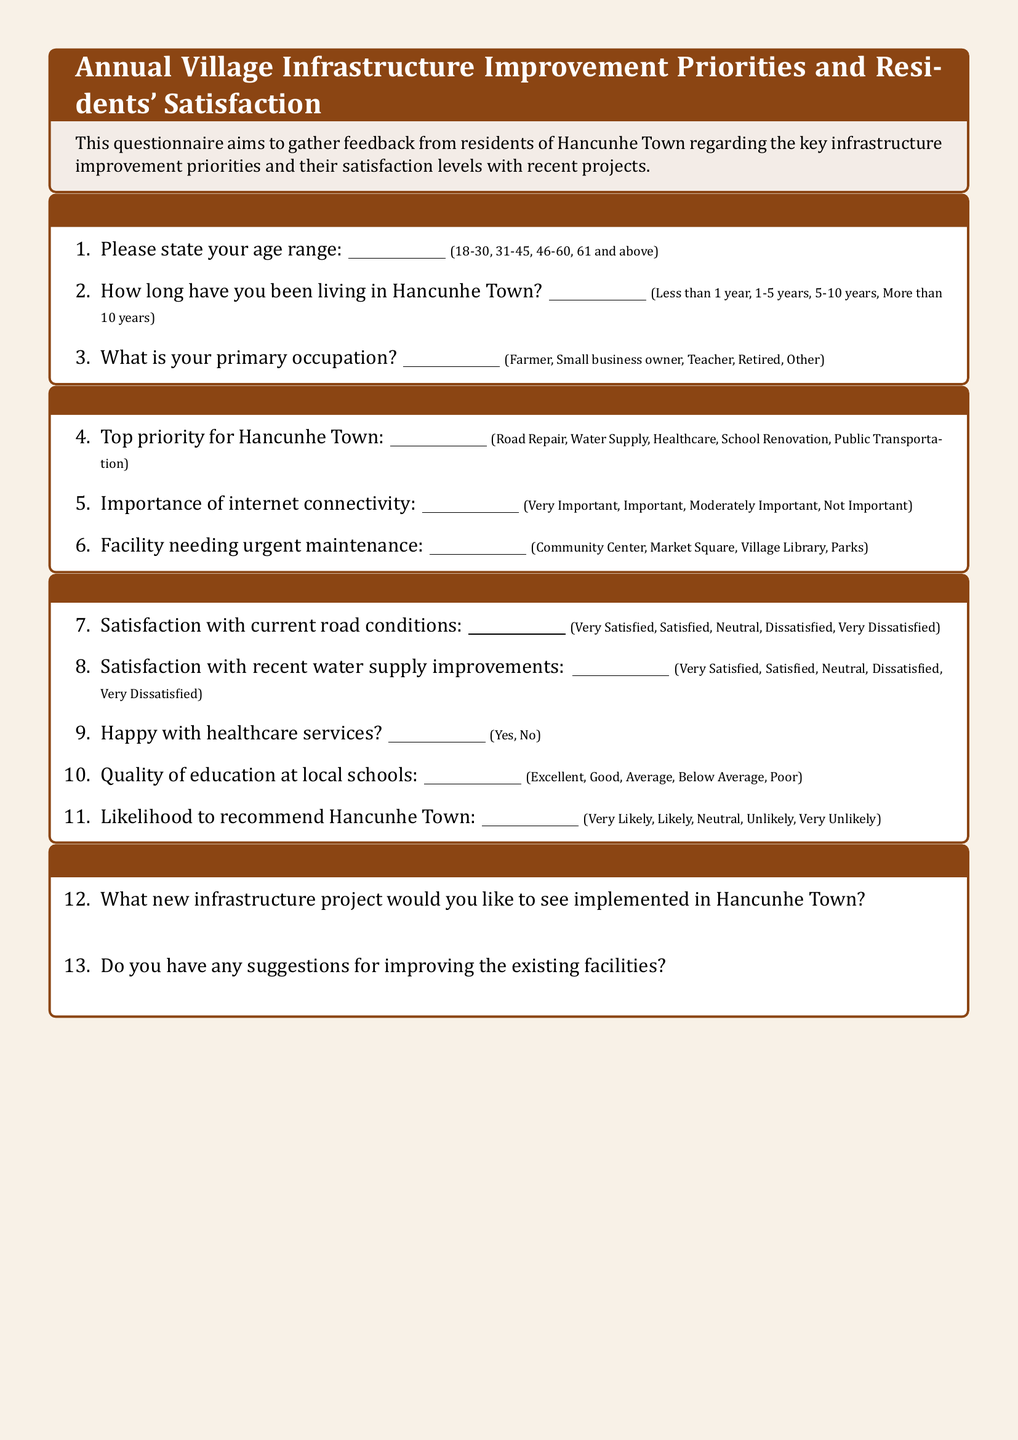what is the age range option provided? The document lists the age range options as 18-30, 31-45, 46-60, 61 and above.
Answer: 18-30, 31-45, 46-60, 61 and above what is the top priority for Hancunhe Town? The top priority can be selected from the options given in the document, which include Road Repair, Water Supply, Healthcare, School Renovation, Public Transportation.
Answer: Road Repair, Water Supply, Healthcare, School Renovation, Public Transportation how many years can you choose for how long you have been living in Hancunhe Town? The document provides four options regarding the duration of residence in Hancunhe Town: Less than 1 year, 1-5 years, 5-10 years, More than 10 years.
Answer: Less than 1 year, 1-5 years, 5-10 years, More than 10 years what is the satisfaction level regarding current road conditions? Respondents can indicate their satisfaction level with current road conditions using the options: Very Satisfied, Satisfied, Neutral, Dissatisfied, Very Dissatisfied.
Answer: Very Satisfied, Satisfied, Neutral, Dissatisfied, Very Dissatisfied what would you like to see implemented in Hancunhe Town? Respondents are asked to suggest a new infrastructure project they would like to see implemented. The response is open-ended in the document.
Answer: New infrastructure project is there a question about healthcare services satisfaction? The document includes a question regarding happiness with healthcare services, offering a simple Yes or No response.
Answer: Yes, No what is the document asking regarding the quality of education? There is a question assessing the quality of education at local schools with options like Excellent, Good, Average, Below Average, Poor.
Answer: Excellent, Good, Average, Below Average, Poor what is the importance of internet connectivity according to the questionnaire? Respondents can state how important internet connectivity is with the options: Very Important, Important, Moderately Important, Not Important.
Answer: Very Important, Important, Moderately Important, Not Important what type of occupation options are provided in the demographic section? The document lists occupation options such as Farmer, Small business owner, Teacher, Retired, Other.
Answer: Farmer, Small business owner, Teacher, Retired, Other 